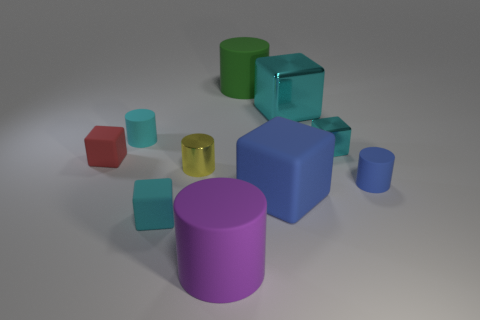Is the material of the tiny cylinder to the left of the yellow metallic cylinder the same as the large blue block?
Offer a terse response. Yes. How many green rubber things have the same shape as the small red rubber object?
Offer a very short reply. 0. What number of tiny things are either purple rubber things or cyan metal objects?
Your answer should be very brief. 1. Is the color of the rubber cylinder on the right side of the blue block the same as the big rubber block?
Provide a succinct answer. Yes. There is a rubber cylinder to the left of the purple rubber thing; is it the same color as the tiny metallic object on the right side of the small metal cylinder?
Your answer should be compact. Yes. Are there any tiny cyan cylinders that have the same material as the large blue block?
Your response must be concise. Yes. How many blue objects are blocks or matte blocks?
Your response must be concise. 1. Is the number of cyan matte cubes in front of the green matte cylinder greater than the number of large red metallic cubes?
Give a very brief answer. Yes. Do the purple object and the blue rubber block have the same size?
Give a very brief answer. Yes. There is a large cube that is made of the same material as the big green cylinder; what color is it?
Provide a succinct answer. Blue. 